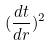Convert formula to latex. <formula><loc_0><loc_0><loc_500><loc_500>( \frac { d t } { d r } ) ^ { 2 }</formula> 